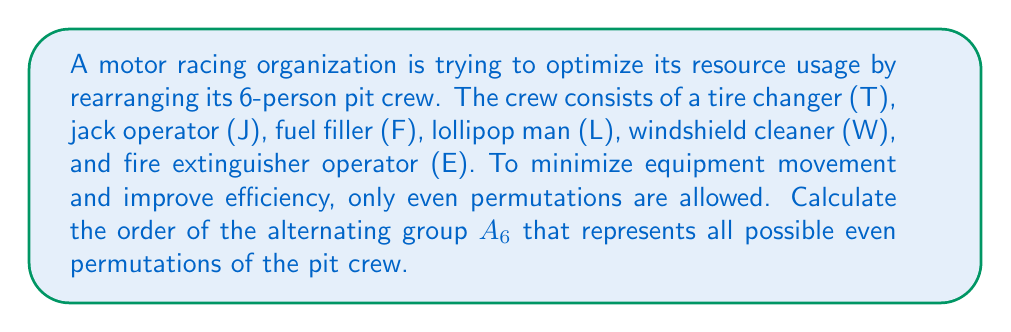Can you answer this question? To solve this problem, we need to follow these steps:

1) First, recall that the alternating group $A_n$ consists of all even permutations of $n$ elements.

2) The order of $A_n$ is given by the formula:

   $$|A_n| = \frac{n!}{2}$$

3) In this case, we have 6 crew members, so we're dealing with $A_6$.

4) Let's calculate:

   $$|A_6| = \frac{6!}{2}$$

5) Expand this:
   
   $$|A_6| = \frac{6 \times 5 \times 4 \times 3 \times 2 \times 1}{2}$$

6) Simplify:
   
   $$|A_6| = 6 \times 5 \times 4 \times 3 \times 1 = 360$$

Therefore, there are 360 possible even permutations of the pit crew.

This result means that the racing organization has 360 different ways to arrange their pit crew while maintaining the constraint of only using even permutations, which helps in optimizing their resource usage and efficiency.
Answer: The order of the alternating group $A_6$, representing all possible even permutations of the 6-person pit crew, is 360. 